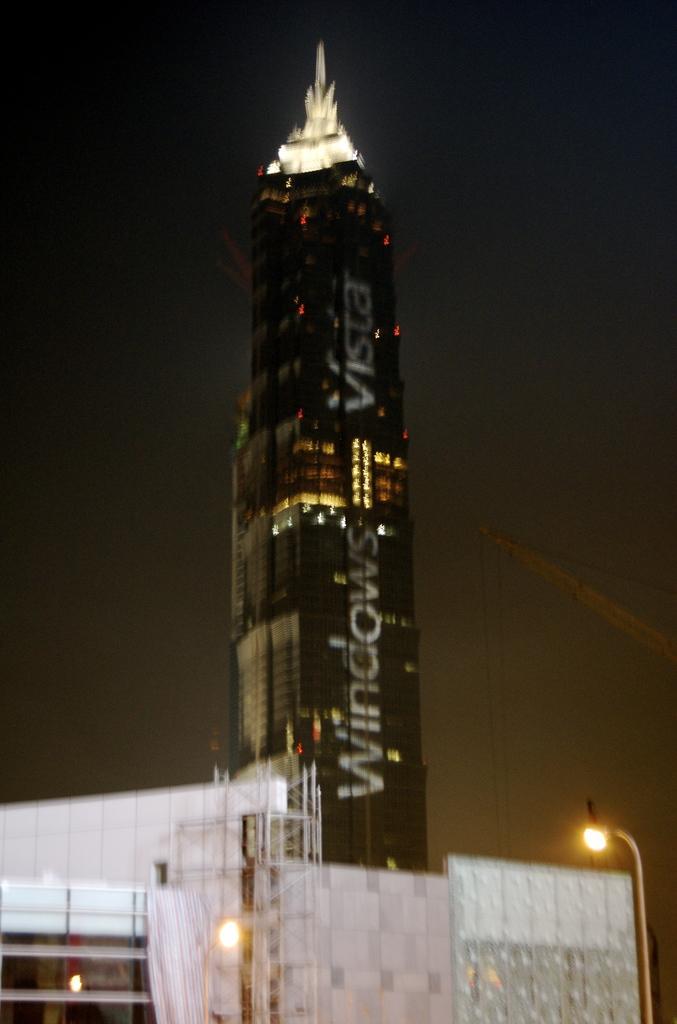In one or two sentences, can you explain what this image depicts? There are buildings and street lights present at the bottom of this image. We can see a tower in the middle of this image and there is a sky in the background. 